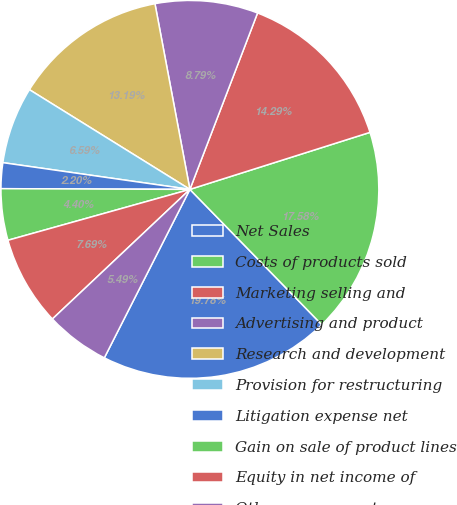<chart> <loc_0><loc_0><loc_500><loc_500><pie_chart><fcel>Net Sales<fcel>Costs of products sold<fcel>Marketing selling and<fcel>Advertising and product<fcel>Research and development<fcel>Provision for restructuring<fcel>Litigation expense net<fcel>Gain on sale of product lines<fcel>Equity in net income of<fcel>Other expense net<nl><fcel>19.78%<fcel>17.58%<fcel>14.29%<fcel>8.79%<fcel>13.19%<fcel>6.59%<fcel>2.2%<fcel>4.4%<fcel>7.69%<fcel>5.49%<nl></chart> 